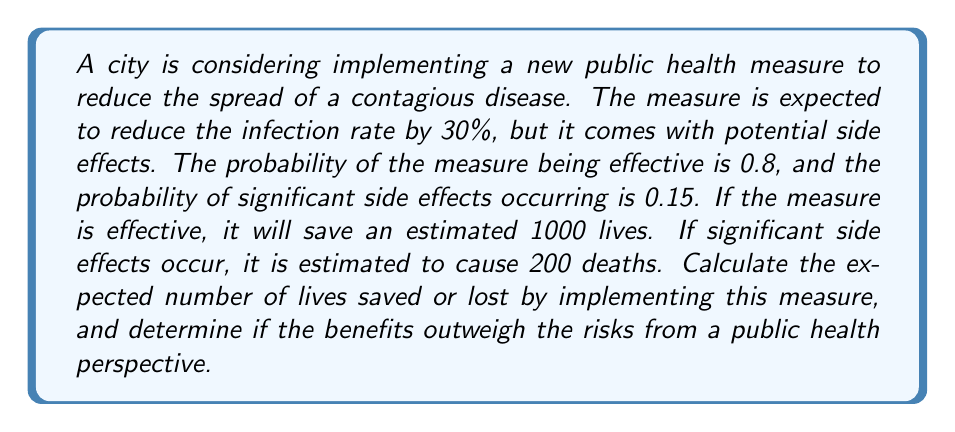Help me with this question. To solve this problem, we need to use decision theory and probabilistic modeling. Let's break it down step by step:

1) First, let's define our events:
   A: The measure is effective (P(A) = 0.8)
   B: Significant side effects occur (P(B) = 0.15)

2) We need to consider four scenarios:
   a) Measure is effective and no significant side effects: P(A and not B)
   b) Measure is effective but significant side effects occur: P(A and B)
   c) Measure is not effective and no significant side effects: P(not A and not B)
   d) Measure is not effective but significant side effects occur: P(not A and B)

3) Calculate the probabilities for each scenario:
   P(A and not B) = P(A) - P(A and B) = 0.8 - (0.8 * 0.15) = 0.68
   P(A and B) = 0.8 * 0.15 = 0.12
   P(not A and not B) = (1 - 0.8) - (0.2 * 0.15) = 0.17
   P(not A and B) = 0.2 * 0.15 = 0.03

4) Calculate the expected outcome for each scenario:
   a) 0.68 * 1000 = 680 lives saved
   b) 0.12 * (1000 - 200) = 96 lives saved
   c) 0.17 * 0 = 0 (no effect)
   d) 0.03 * (-200) = -6 lives lost

5) Sum up the expected outcomes:
   Total expected outcome = 680 + 96 + 0 - 6 = 770 lives saved

The expected number of lives saved by implementing this measure is 770.

To determine if the benefits outweigh the risks, we compare the expected number of lives saved (770) to the potential lives lost due to side effects (200). Since the expected number of lives saved is significantly higher than the potential lives lost, the benefits outweigh the risks from a public health perspective.
Answer: The expected number of lives saved by implementing the public health measure is 770. The benefits outweigh the risks, as the expected number of lives saved (770) is significantly higher than the potential lives lost due to side effects (200). 